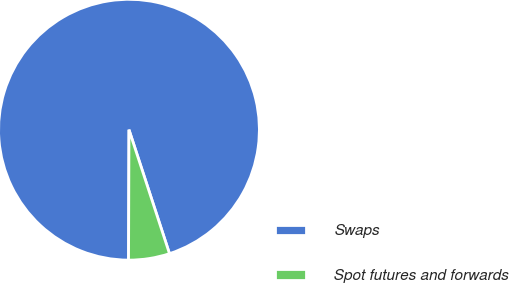Convert chart. <chart><loc_0><loc_0><loc_500><loc_500><pie_chart><fcel>Swaps<fcel>Spot futures and forwards<nl><fcel>94.92%<fcel>5.08%<nl></chart> 